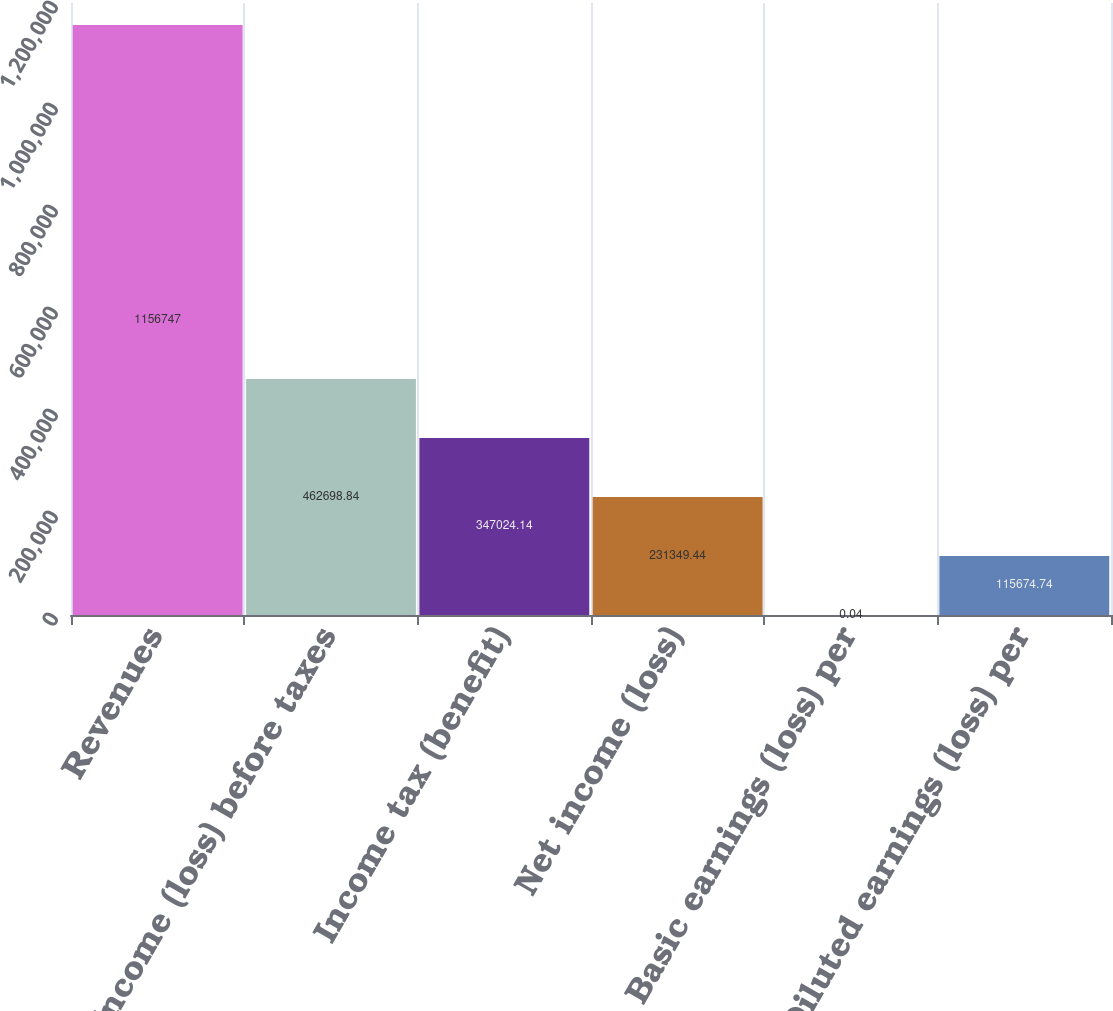Convert chart. <chart><loc_0><loc_0><loc_500><loc_500><bar_chart><fcel>Revenues<fcel>Income (loss) before taxes<fcel>Income tax (benefit)<fcel>Net income (loss)<fcel>Basic earnings (loss) per<fcel>Diluted earnings (loss) per<nl><fcel>1.15675e+06<fcel>462699<fcel>347024<fcel>231349<fcel>0.04<fcel>115675<nl></chart> 